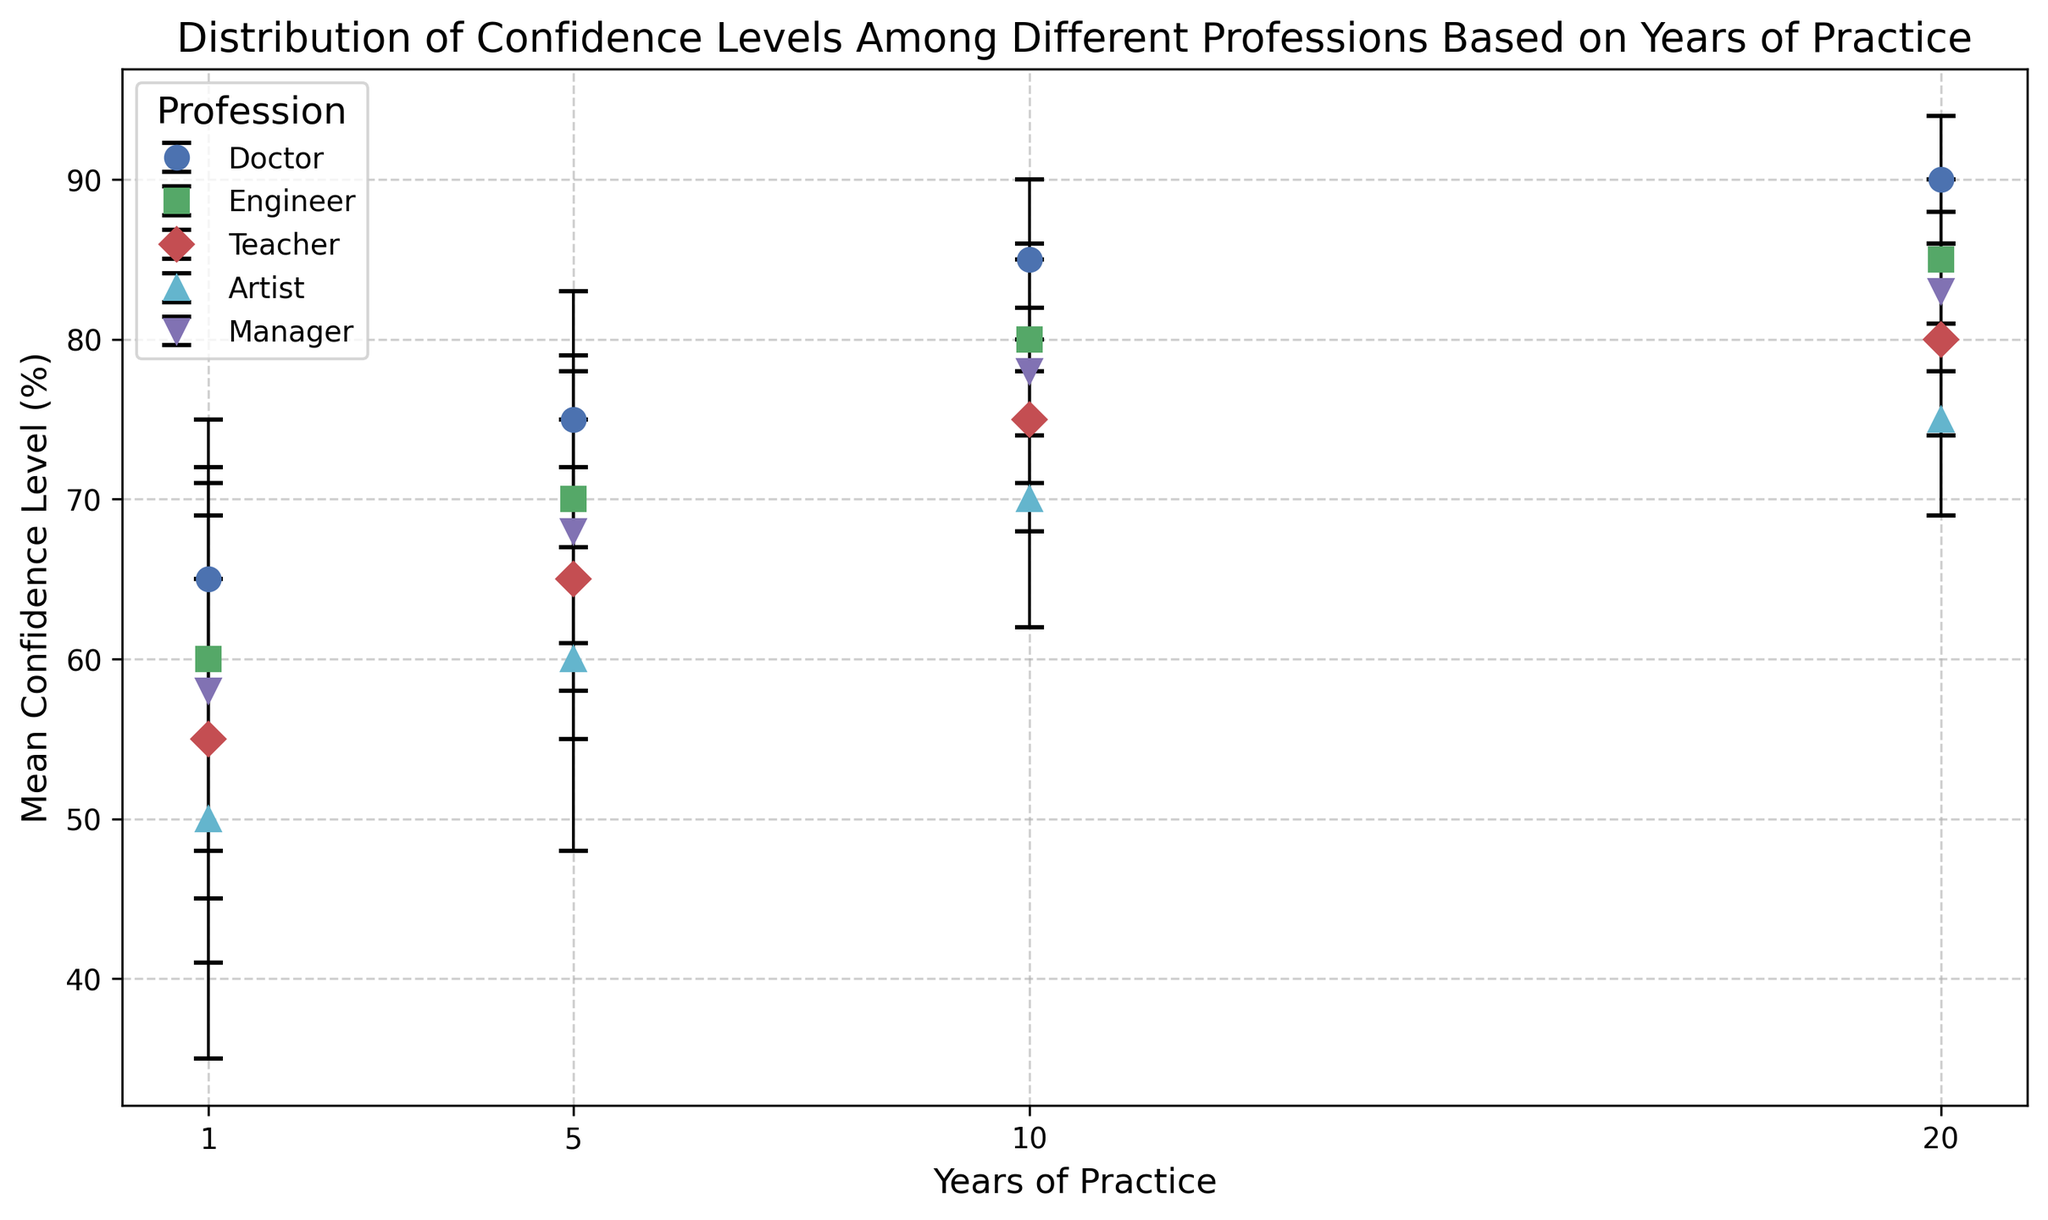Which profession has the highest mean confidence level after 20 years of practice? By looking at the endpoint of the error bars for each profession at 20 years, we see that Doctors have the highest mean confidence level.
Answer: Doctors Which profession shows the largest increase in mean confidence level from 1 year to 20 years of practice? To determine this, we compare the difference in mean confidence levels at 1 year and 20 years for each profession. Doctors have gone from 65 to 90, Engineers from 60 to 85, Teachers from 55 to 80, Artists from 50 to 75, and Managers from 58 to 83. The differences are 25, 25, 25, 25, and 25 respectively. All professions show the same increase.
Answer: All professions (equal) How does the mean confidence level of Engineers after 10 years compare to the mean confidence level of Teachers after 20 years? By comparing the data points at 10 years for Engineers (80) and 20 years for Teachers (80), we see that both have the same mean confidence level.
Answer: Equal Which profession has the largest standard deviation in mean confidence level at 1 year? By examining the error bars at 1 year, Artists have the largest standard deviation (15).
Answer: Artists At 5 years of practice, which profession has the smallest confidence interval for mean confidence level? By looking at the length of the error bars at 5 years, we see that Doctors have the smallest confidence interval (from 67 to 83, which is 16).
Answer: Doctors Is the mean confidence level of Managers after 20 years greater than that of Engineers after 20 years? We compare the endpoint mean values at 20 years for both professions. Managers have a mean confidence level of 83, and Engineers have 85. Therefore, Engineers have a higher mean confidence level.
Answer: No Calculate the average mean confidence level for Teachers over the given years of practice. We sum the mean confidence levels for Teachers at 1, 5, 10, and 20 years (55 + 65 + 75 + 80) and then divide by 4. The total is 275, so the average is 275/4 = 68.75.
Answer: 68.75 Which profession has the smallest mean confidence level at 1 year and the largest at 20 years? By looking at the mean confidence levels at 1 year and 20 years, Artists have the smallest mean confidence level at 1 year (50), and Doctors have the largest at 20 years (90).
Answer: Artists (1 year), Doctors (20 years) Do all professions show an increase in mean confidence level with years of practice? By observing the error bars for all professions over the years, we see that every profession shows a progressive increase in mean confidence level as years of practice increase.
Answer: Yes What is the difference between the mean confidence levels of Doctors and Engineers at 10 years? The mean confidence level of Doctors at 10 years is 85, and for Engineers, it is 80. By subtracting Engineers' mean confidence level from Doctors', the difference is 85 - 80 = 5.
Answer: 5 